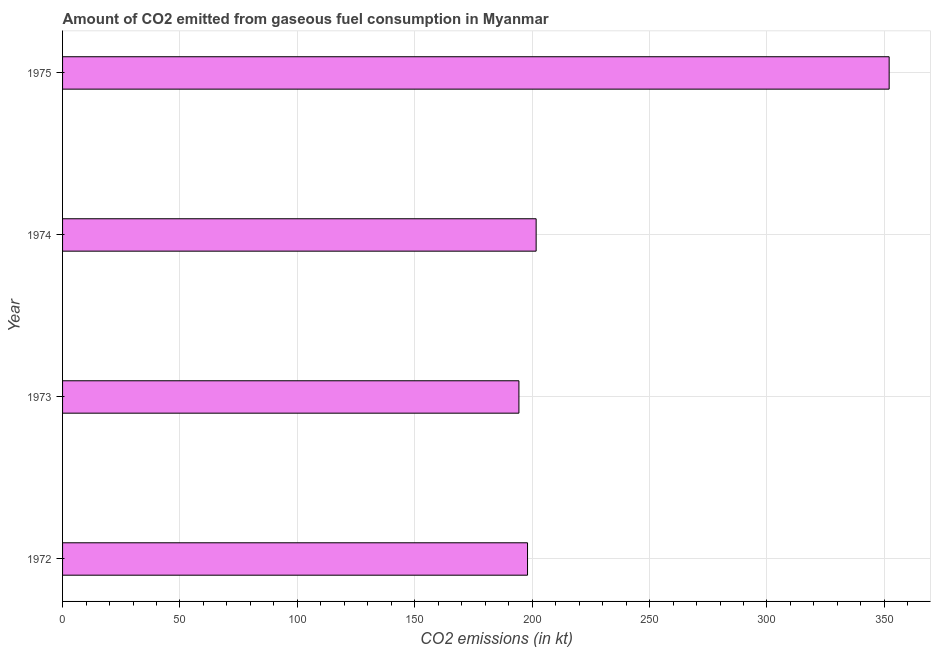Does the graph contain any zero values?
Offer a terse response. No. What is the title of the graph?
Give a very brief answer. Amount of CO2 emitted from gaseous fuel consumption in Myanmar. What is the label or title of the X-axis?
Keep it short and to the point. CO2 emissions (in kt). What is the label or title of the Y-axis?
Make the answer very short. Year. What is the co2 emissions from gaseous fuel consumption in 1974?
Provide a succinct answer. 201.69. Across all years, what is the maximum co2 emissions from gaseous fuel consumption?
Provide a short and direct response. 352.03. Across all years, what is the minimum co2 emissions from gaseous fuel consumption?
Ensure brevity in your answer.  194.35. In which year was the co2 emissions from gaseous fuel consumption maximum?
Give a very brief answer. 1975. What is the sum of the co2 emissions from gaseous fuel consumption?
Make the answer very short. 946.09. What is the difference between the co2 emissions from gaseous fuel consumption in 1972 and 1975?
Make the answer very short. -154.01. What is the average co2 emissions from gaseous fuel consumption per year?
Provide a succinct answer. 236.52. What is the median co2 emissions from gaseous fuel consumption?
Make the answer very short. 199.85. What is the ratio of the co2 emissions from gaseous fuel consumption in 1972 to that in 1973?
Give a very brief answer. 1.02. Is the difference between the co2 emissions from gaseous fuel consumption in 1973 and 1974 greater than the difference between any two years?
Offer a terse response. No. What is the difference between the highest and the second highest co2 emissions from gaseous fuel consumption?
Offer a very short reply. 150.35. What is the difference between the highest and the lowest co2 emissions from gaseous fuel consumption?
Keep it short and to the point. 157.68. In how many years, is the co2 emissions from gaseous fuel consumption greater than the average co2 emissions from gaseous fuel consumption taken over all years?
Your response must be concise. 1. Are all the bars in the graph horizontal?
Your response must be concise. Yes. How many years are there in the graph?
Ensure brevity in your answer.  4. What is the difference between two consecutive major ticks on the X-axis?
Make the answer very short. 50. Are the values on the major ticks of X-axis written in scientific E-notation?
Ensure brevity in your answer.  No. What is the CO2 emissions (in kt) in 1972?
Offer a terse response. 198.02. What is the CO2 emissions (in kt) in 1973?
Your response must be concise. 194.35. What is the CO2 emissions (in kt) in 1974?
Ensure brevity in your answer.  201.69. What is the CO2 emissions (in kt) of 1975?
Make the answer very short. 352.03. What is the difference between the CO2 emissions (in kt) in 1972 and 1973?
Ensure brevity in your answer.  3.67. What is the difference between the CO2 emissions (in kt) in 1972 and 1974?
Your response must be concise. -3.67. What is the difference between the CO2 emissions (in kt) in 1972 and 1975?
Provide a short and direct response. -154.01. What is the difference between the CO2 emissions (in kt) in 1973 and 1974?
Offer a terse response. -7.33. What is the difference between the CO2 emissions (in kt) in 1973 and 1975?
Your answer should be compact. -157.68. What is the difference between the CO2 emissions (in kt) in 1974 and 1975?
Keep it short and to the point. -150.35. What is the ratio of the CO2 emissions (in kt) in 1972 to that in 1973?
Make the answer very short. 1.02. What is the ratio of the CO2 emissions (in kt) in 1972 to that in 1974?
Provide a short and direct response. 0.98. What is the ratio of the CO2 emissions (in kt) in 1972 to that in 1975?
Your answer should be compact. 0.56. What is the ratio of the CO2 emissions (in kt) in 1973 to that in 1974?
Offer a very short reply. 0.96. What is the ratio of the CO2 emissions (in kt) in 1973 to that in 1975?
Your answer should be very brief. 0.55. What is the ratio of the CO2 emissions (in kt) in 1974 to that in 1975?
Offer a very short reply. 0.57. 